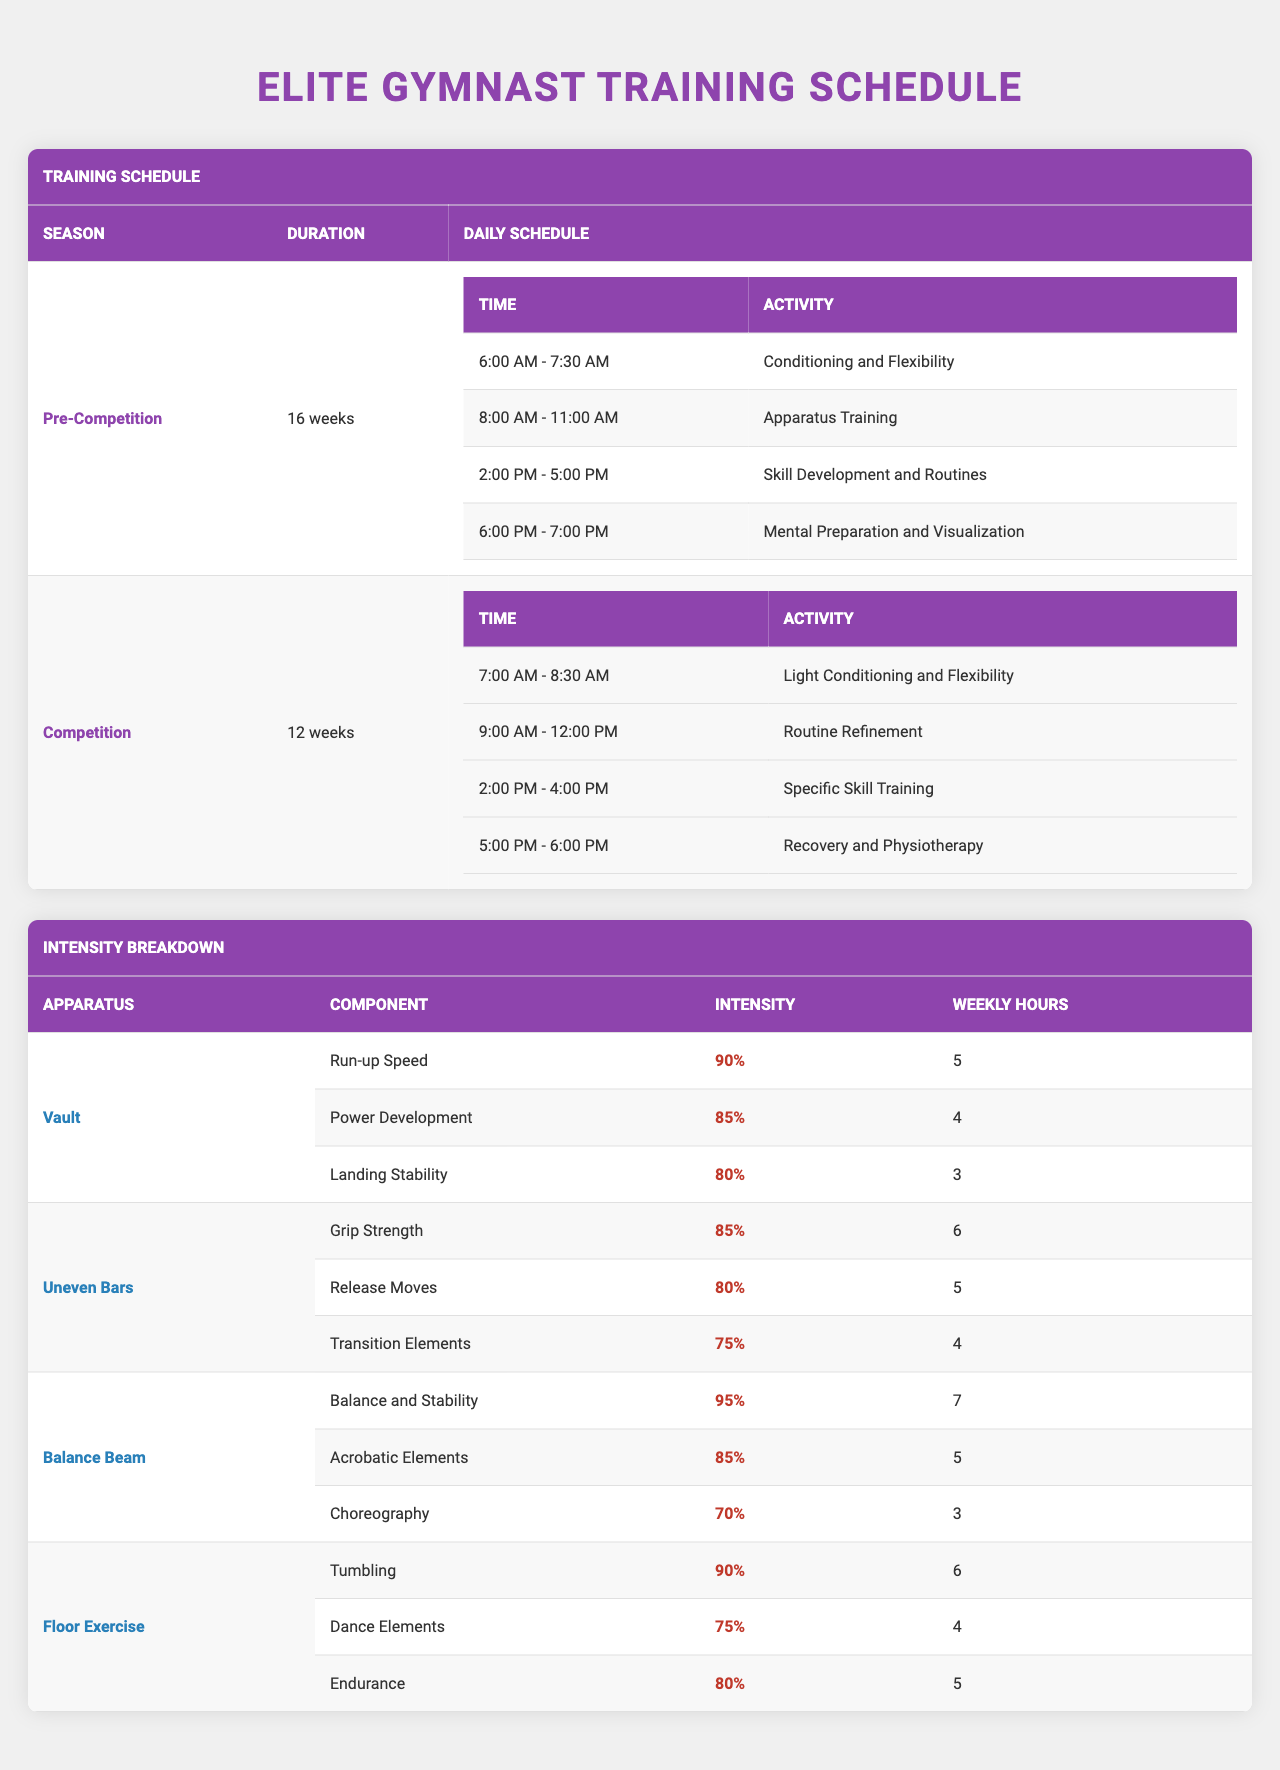What is the duration of the Pre-Competition season? The table displays "Pre-Competition" with a corresponding duration of "16 weeks."
Answer: 16 weeks How many hours are allocated weekly for "Run-up Speed" training on the Vault? The breakdown for the Vault apparatus mentions "Run-up Speed" with an intensity of "90%" and "Weekly Hours" of 5.
Answer: 5 hours Which activity takes place from 6:00 PM to 7:00 PM during the Pre-Competition season? The Pre-Competition schedule lists "Mental Preparation and Visualization" for the time slot between 6:00 PM and 7:00 PM.
Answer: Mental Preparation and Visualization What is the component with the highest intensity in the Balance Beam training? In the "Balance Beam" section, "Balance and Stability" has the highest intensity at "95%."
Answer: Balance and Stability What is the total number of weekly training hours for the Uneven Bars components? The training components for Uneven Bars are "Grip Strength" (6 hours), "Release Moves" (5 hours), and "Transition Elements" (4 hours). Summing these gives: 6 + 5 + 4 = 15 hours.
Answer: 15 hours Are there any activities scheduled for 7:00 AM during the Competition season? Yes, "Light Conditioning and Flexibility" is scheduled from 7:00 AM to 8:30 AM during the Competition season.
Answer: Yes How many hours are dedicated to "Acrobatic Elements" training on the Balance Beam? The Balance Beam training shows "Acrobatic Elements" with "Weekly Hours" of 5.
Answer: 5 hours Which apparatus has the highest weekly training hours for any single component? The Balance Beam has "Balance and Stability" with "Weekly Hours" of 7, higher than other components in different apparatus.
Answer: Balance Beam If a gymnast spends 5 hours on "Recovery and Physiotherapy" weekly, what percentage of their weekly training would that represent if they train 30 hours total? The percentage is calculated as (5 / 30) * 100 = 16.67%.
Answer: 16.67% How does the intensity of "Dance Elements" in Floor Exercise compare to "Landing Stability" in Vault? "Dance Elements" has an intensity of "75%" while "Landing Stability" has an intensity of "80%." Since 75% < 80%, "Landing Stability" is more intense.
Answer: Landing Stability is more intense 